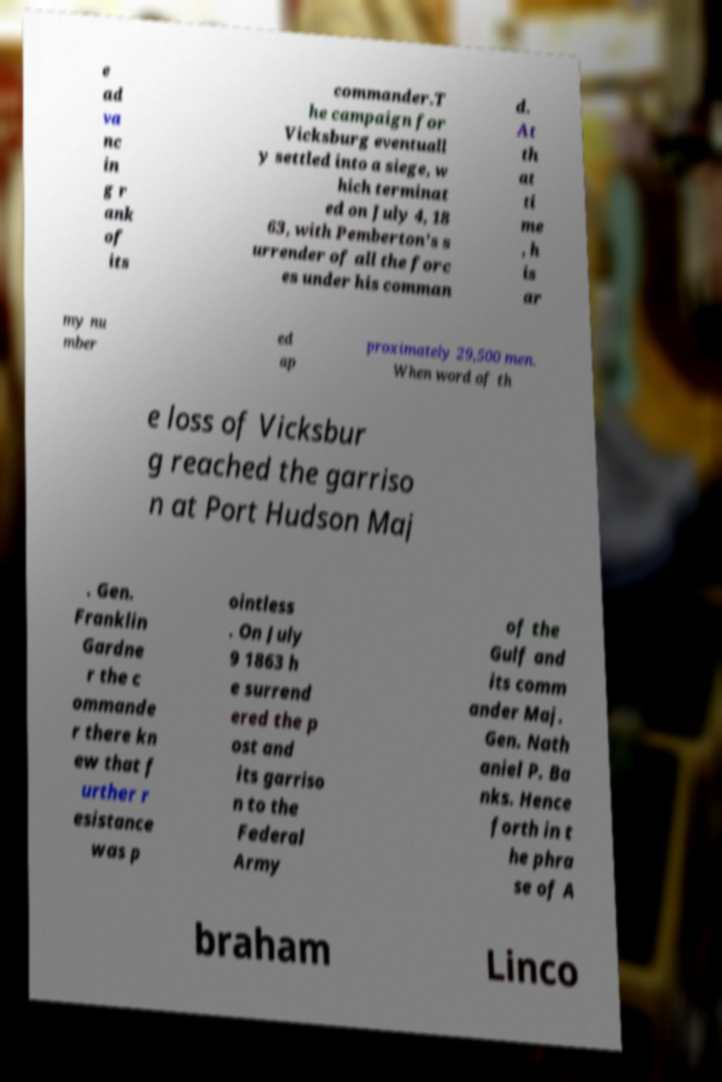For documentation purposes, I need the text within this image transcribed. Could you provide that? e ad va nc in g r ank of its commander.T he campaign for Vicksburg eventuall y settled into a siege, w hich terminat ed on July 4, 18 63, with Pemberton's s urrender of all the forc es under his comman d. At th at ti me , h is ar my nu mber ed ap proximately 29,500 men. When word of th e loss of Vicksbur g reached the garriso n at Port Hudson Maj . Gen. Franklin Gardne r the c ommande r there kn ew that f urther r esistance was p ointless . On July 9 1863 h e surrend ered the p ost and its garriso n to the Federal Army of the Gulf and its comm ander Maj. Gen. Nath aniel P. Ba nks. Hence forth in t he phra se of A braham Linco 